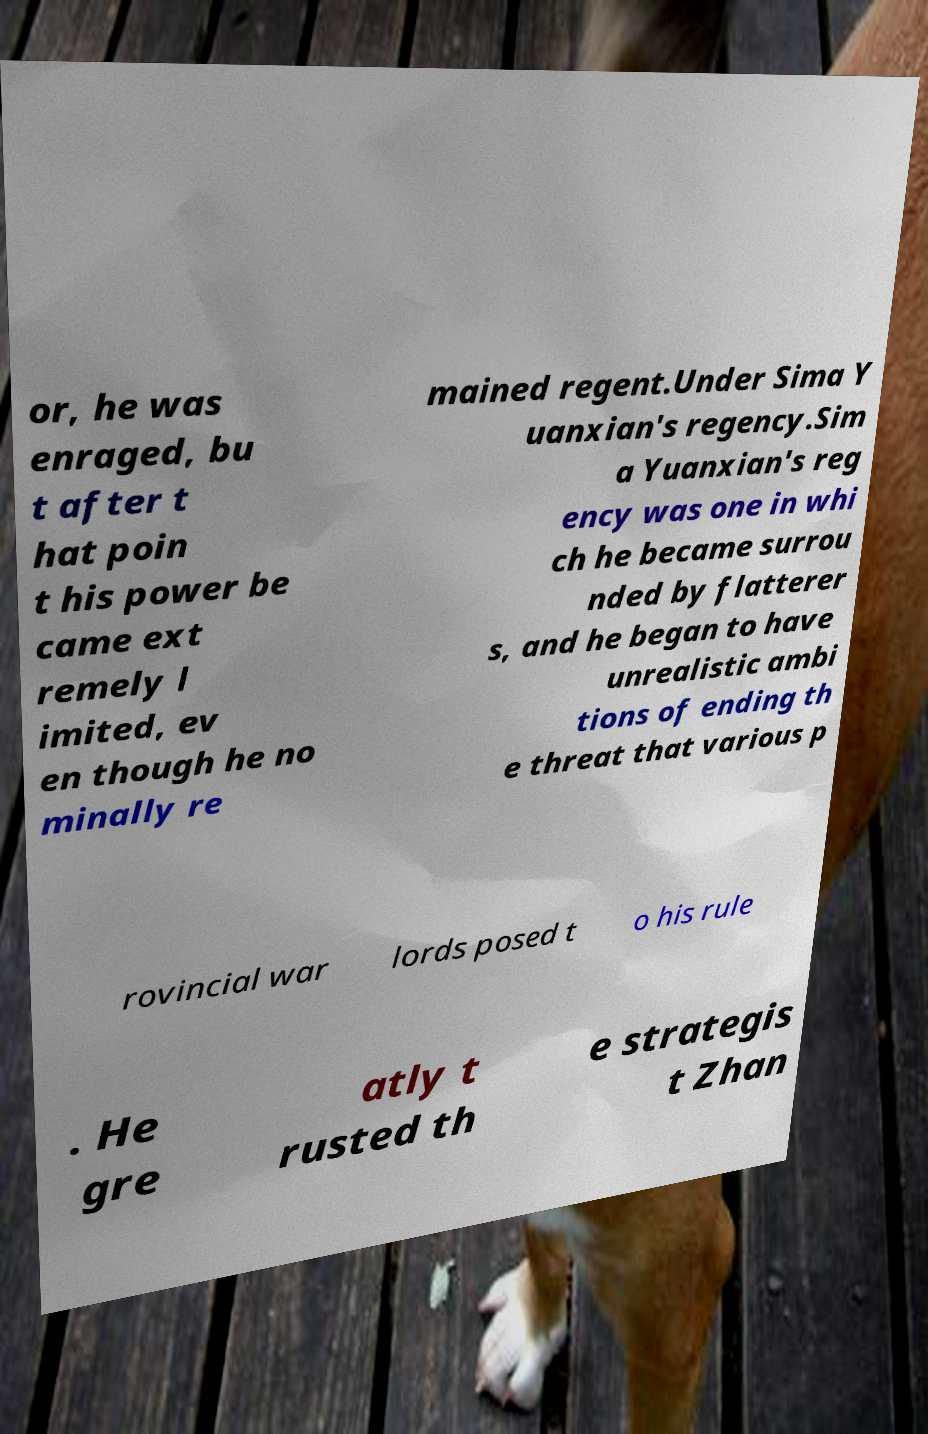Can you accurately transcribe the text from the provided image for me? or, he was enraged, bu t after t hat poin t his power be came ext remely l imited, ev en though he no minally re mained regent.Under Sima Y uanxian's regency.Sim a Yuanxian's reg ency was one in whi ch he became surrou nded by flatterer s, and he began to have unrealistic ambi tions of ending th e threat that various p rovincial war lords posed t o his rule . He gre atly t rusted th e strategis t Zhan 